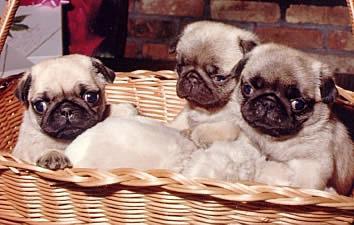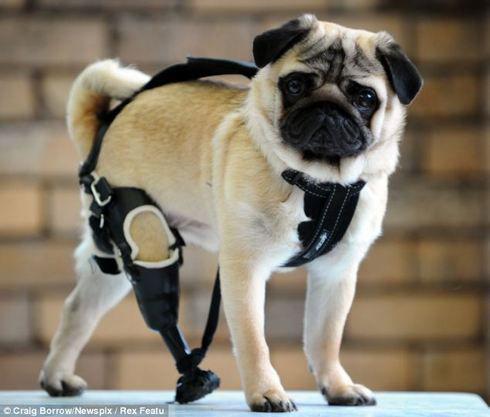The first image is the image on the left, the second image is the image on the right. Considering the images on both sides, is "An image features three pugs in costumes that include fur trimming." valid? Answer yes or no. No. The first image is the image on the left, the second image is the image on the right. Assess this claim about the two images: "There are exactly three dogs in the right image.". Correct or not? Answer yes or no. No. 